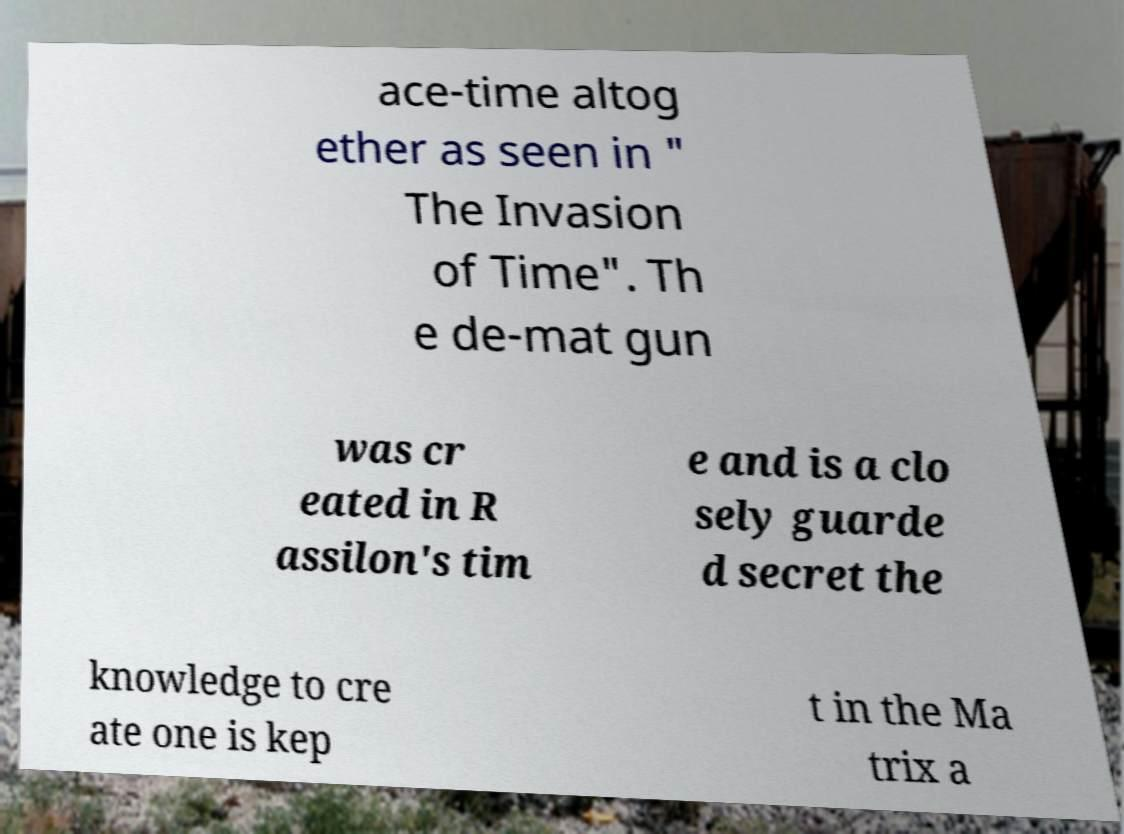What messages or text are displayed in this image? I need them in a readable, typed format. ace-time altog ether as seen in " The Invasion of Time". Th e de-mat gun was cr eated in R assilon's tim e and is a clo sely guarde d secret the knowledge to cre ate one is kep t in the Ma trix a 